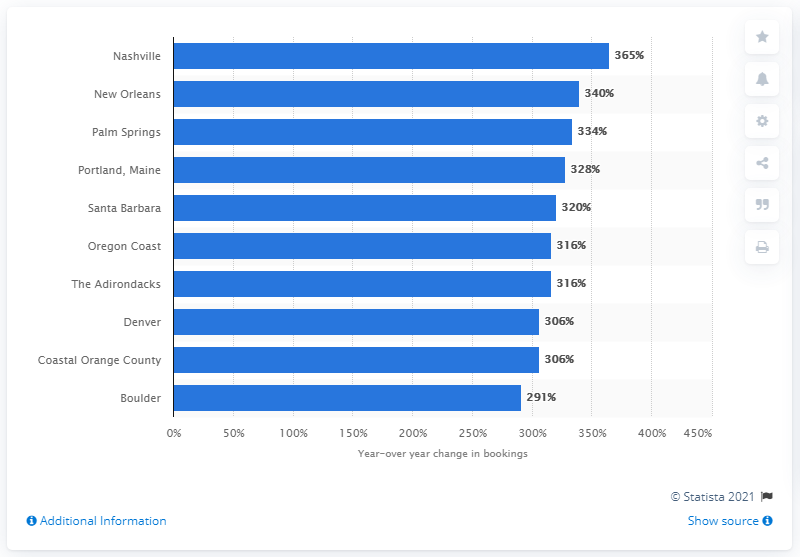Identify some key points in this picture. In 2014, Nashville was the fastest growing summer destination for Airbnb bookings in the United States. 